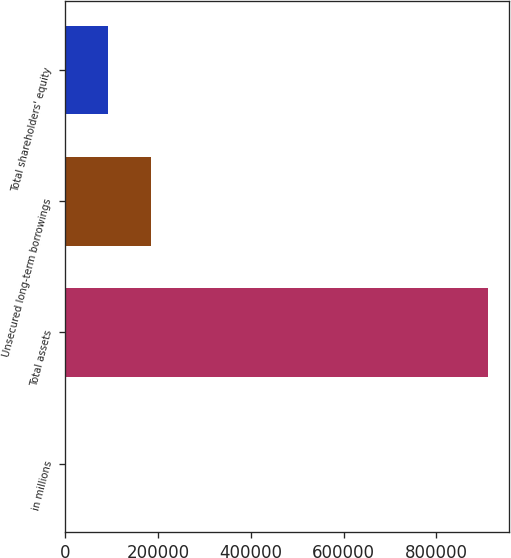<chart> <loc_0><loc_0><loc_500><loc_500><bar_chart><fcel>in millions<fcel>Total assets<fcel>Unsecured long-term borrowings<fcel>Total shareholders' equity<nl><fcel>2013<fcel>911507<fcel>183912<fcel>92962.4<nl></chart> 